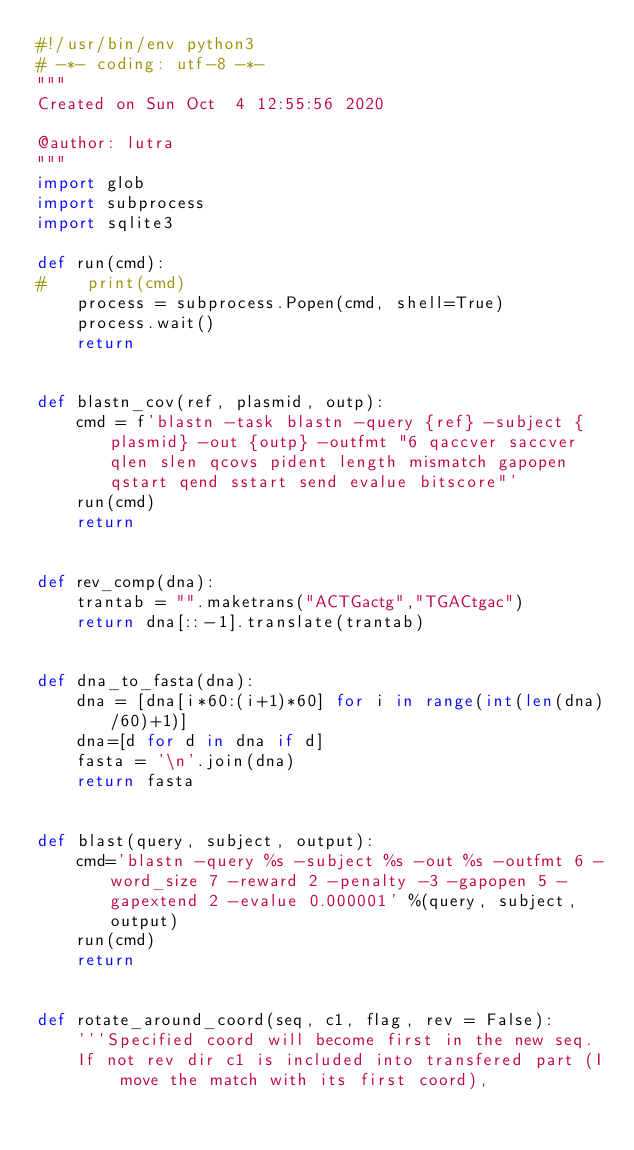<code> <loc_0><loc_0><loc_500><loc_500><_Python_>#!/usr/bin/env python3
# -*- coding: utf-8 -*-
"""
Created on Sun Oct  4 12:55:56 2020

@author: lutra
"""
import glob
import subprocess
import sqlite3

def run(cmd):
#    print(cmd)
    process = subprocess.Popen(cmd, shell=True)
    process.wait()
    return


def blastn_cov(ref, plasmid, outp):
    cmd = f'blastn -task blastn -query {ref} -subject {plasmid} -out {outp} -outfmt "6 qaccver saccver qlen slen qcovs pident length mismatch gapopen qstart qend sstart send evalue bitscore"'
    run(cmd)
    return


def rev_comp(dna):
    trantab = "".maketrans("ACTGactg","TGACtgac")
    return dna[::-1].translate(trantab)


def dna_to_fasta(dna):
    dna = [dna[i*60:(i+1)*60] for i in range(int(len(dna)/60)+1)]
    dna=[d for d in dna if d]
    fasta = '\n'.join(dna)
    return fasta


def blast(query, subject, output):
    cmd='blastn -query %s -subject %s -out %s -outfmt 6 -word_size 7 -reward 2 -penalty -3 -gapopen 5 -gapextend 2 -evalue 0.000001' %(query, subject, output)
    run(cmd)
    return
    

def rotate_around_coord(seq, c1, flag, rev = False):
    '''Specified coord will become first in the new seq.
    If not rev dir c1 is included into transfered part (I move the match with its first coord), </code> 